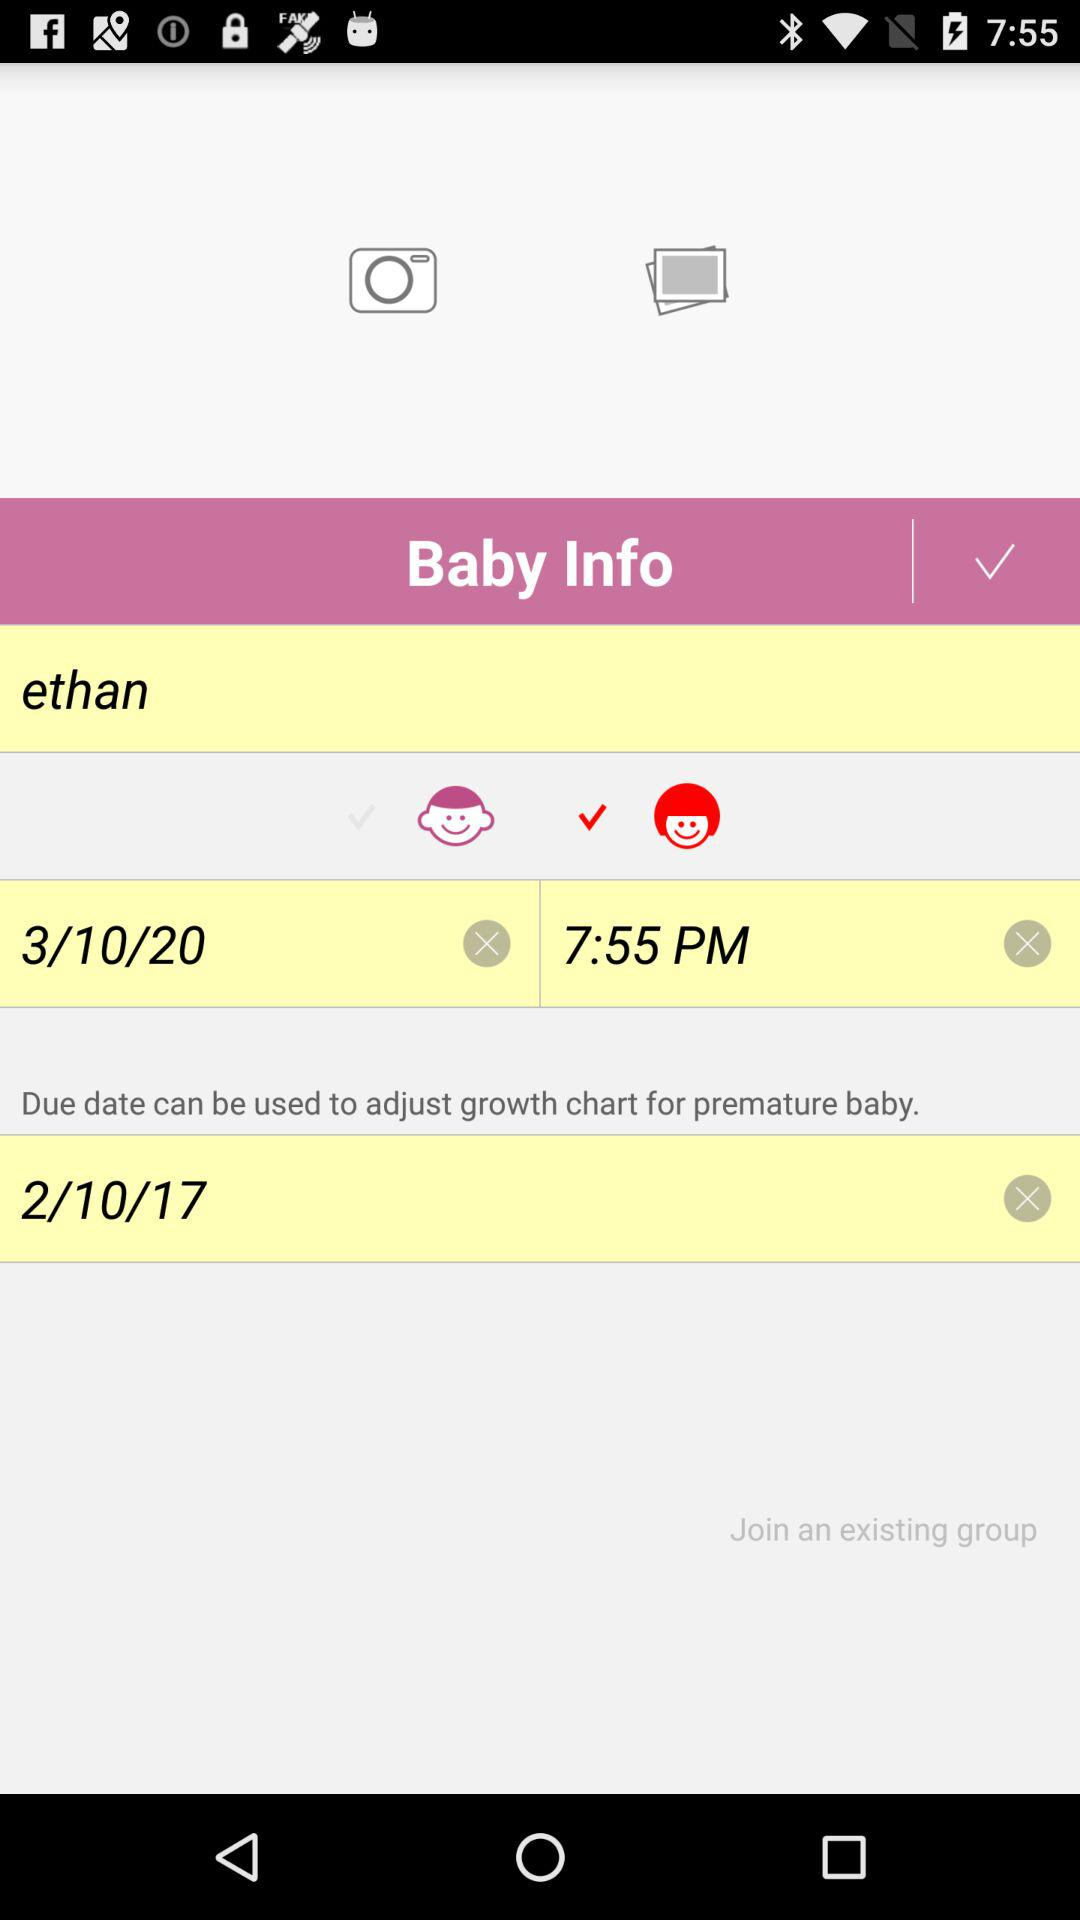What is the name of the baby? The name of the baby is "ethan". 